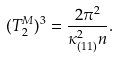<formula> <loc_0><loc_0><loc_500><loc_500>( T _ { 2 } ^ { M } ) ^ { 3 } = \frac { 2 \pi ^ { 2 } } { \kappa _ { ( 1 1 ) } ^ { 2 } n } .</formula> 